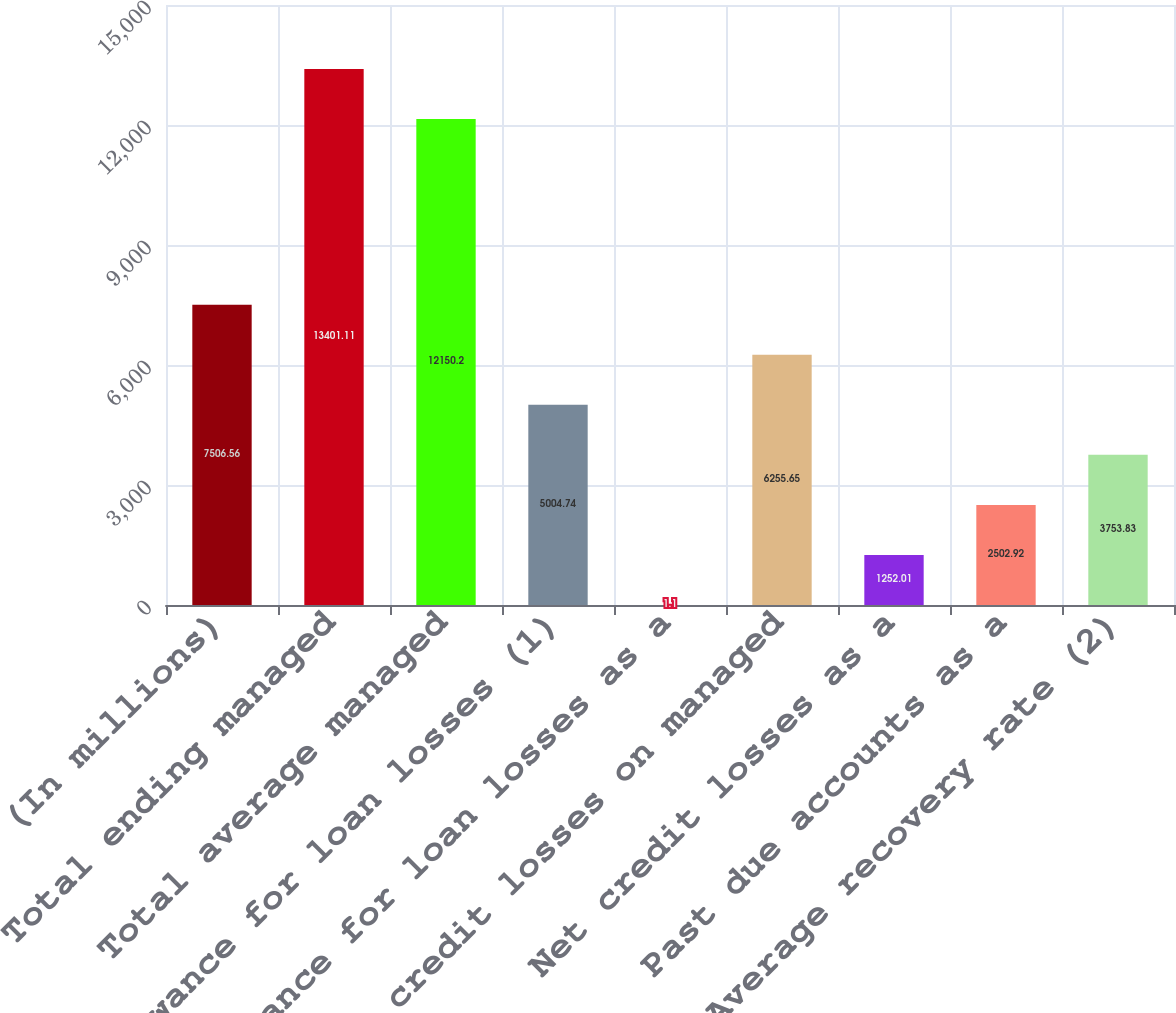Convert chart. <chart><loc_0><loc_0><loc_500><loc_500><bar_chart><fcel>(In millions)<fcel>Total ending managed<fcel>Total average managed<fcel>Allowance for loan losses (1)<fcel>Allowance for loan losses as a<fcel>Net credit losses on managed<fcel>Net credit losses as a<fcel>Past due accounts as a<fcel>Average recovery rate (2)<nl><fcel>7506.56<fcel>13401.1<fcel>12150.2<fcel>5004.74<fcel>1.1<fcel>6255.65<fcel>1252.01<fcel>2502.92<fcel>3753.83<nl></chart> 